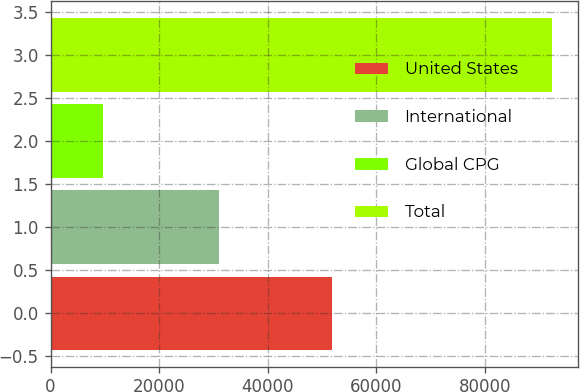<chart> <loc_0><loc_0><loc_500><loc_500><bar_chart><fcel>United States<fcel>International<fcel>Global CPG<fcel>Total<nl><fcel>51802<fcel>30972<fcel>9700<fcel>92474<nl></chart> 